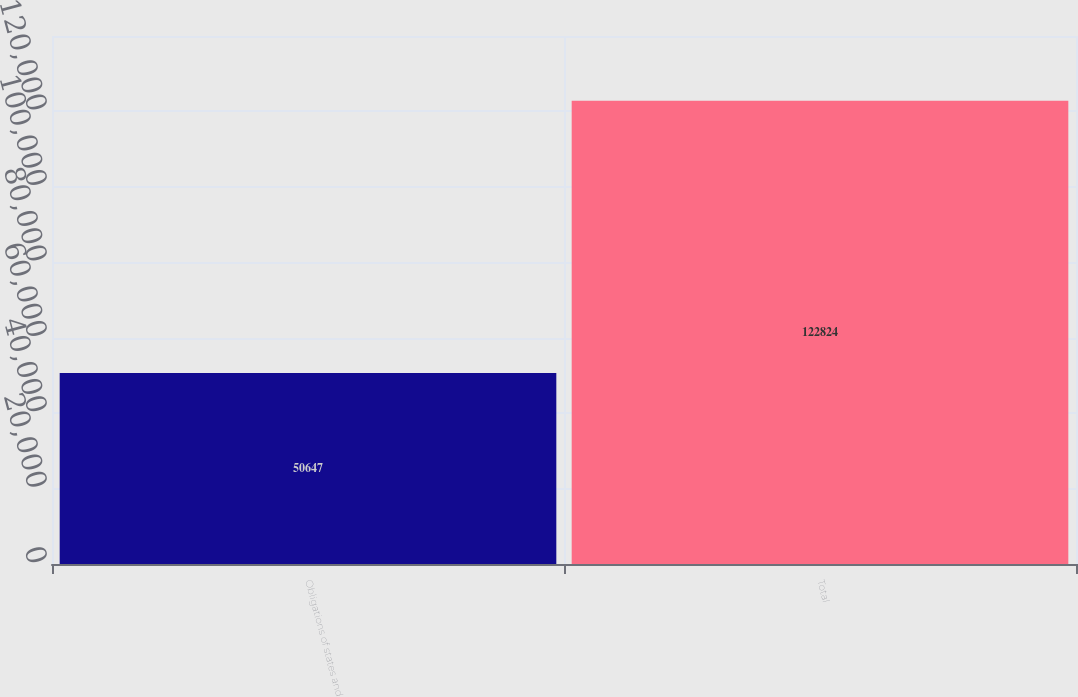Convert chart to OTSL. <chart><loc_0><loc_0><loc_500><loc_500><bar_chart><fcel>Obligations of states and<fcel>Total<nl><fcel>50647<fcel>122824<nl></chart> 